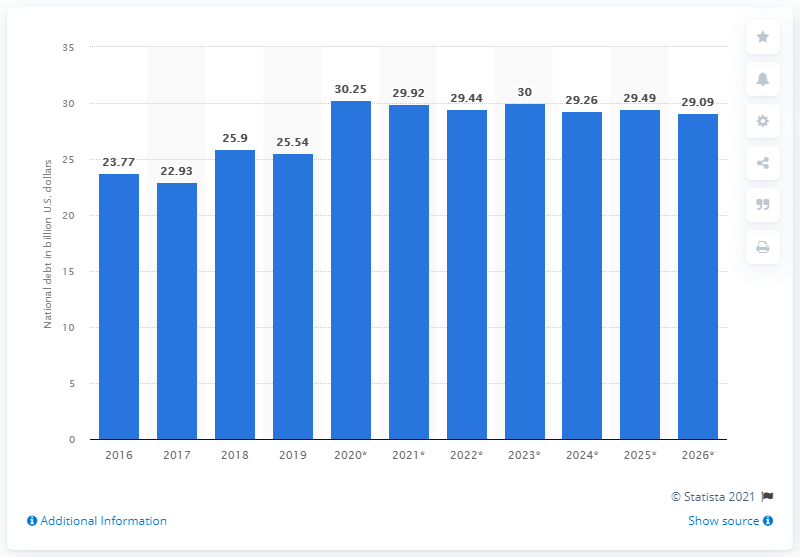Draw attention to some important aspects in this diagram. In 2019, the national debt of Cyprus was approximately 25.54 billion dollars. 